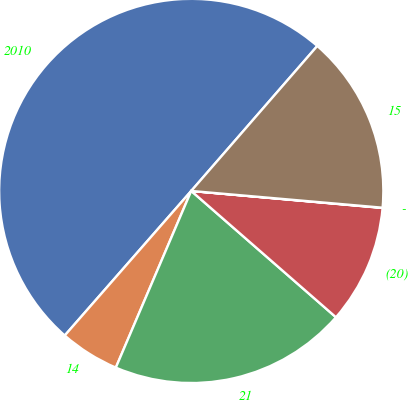Convert chart to OTSL. <chart><loc_0><loc_0><loc_500><loc_500><pie_chart><fcel>2010<fcel>14<fcel>21<fcel>(20)<fcel>-<fcel>15<nl><fcel>49.95%<fcel>5.02%<fcel>20.0%<fcel>10.01%<fcel>0.02%<fcel>15.0%<nl></chart> 